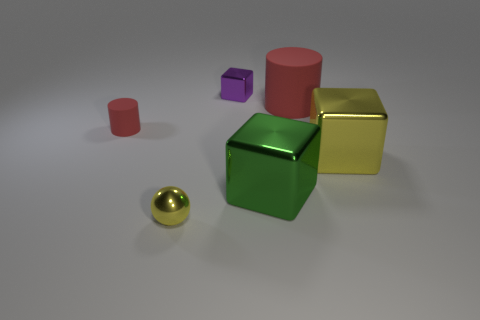What number of things are either tiny metal objects in front of the small red rubber cylinder or tiny purple blocks?
Provide a succinct answer. 2. There is a cube behind the red cylinder left of the small shiny object that is on the left side of the small purple metal cube; what is its material?
Ensure brevity in your answer.  Metal. Are there more yellow balls on the left side of the large yellow shiny thing than tiny matte cylinders that are in front of the small yellow thing?
Make the answer very short. Yes. What number of spheres are either tiny yellow things or blue metallic objects?
Your response must be concise. 1. There is a red object that is in front of the matte thing right of the small rubber object; what number of purple objects are right of it?
Make the answer very short. 1. There is a big cylinder that is the same color as the small matte object; what is its material?
Make the answer very short. Rubber. Is the number of large rubber things greater than the number of red shiny objects?
Your answer should be compact. Yes. Does the purple shiny cube have the same size as the ball?
Offer a terse response. Yes. What number of things are tiny purple rubber things or big yellow shiny things?
Make the answer very short. 1. There is a yellow metallic thing on the left side of the matte object right of the yellow object on the left side of the large yellow thing; what is its shape?
Your answer should be compact. Sphere. 